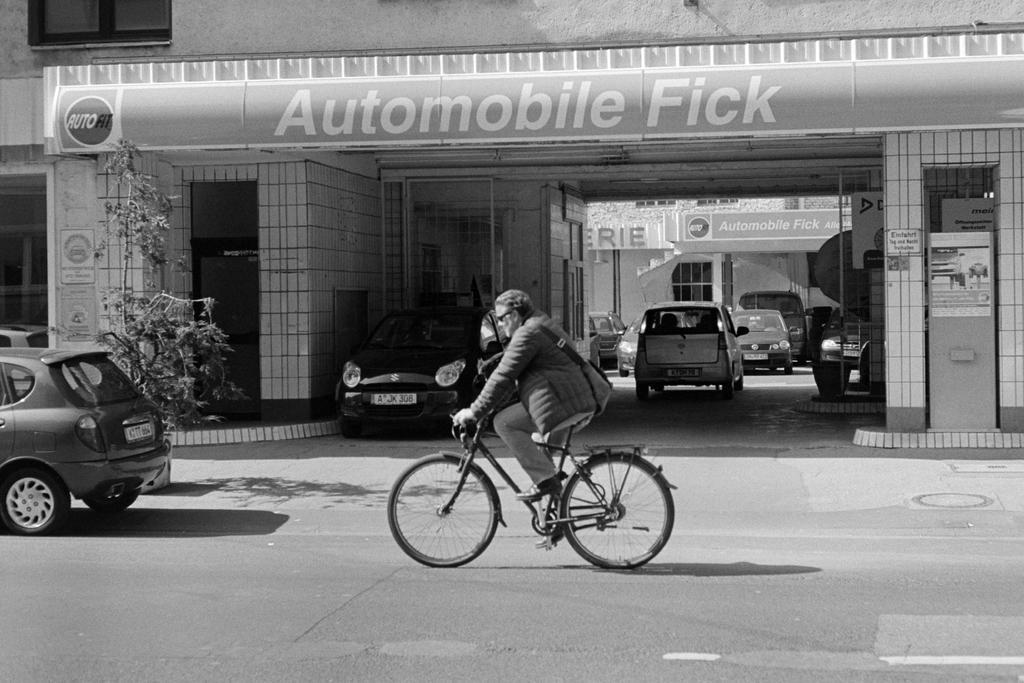Can you describe this image briefly? In this picture we can see a man is riding a bicycle on the road and also we can find couple of cars, plants and buildings. 